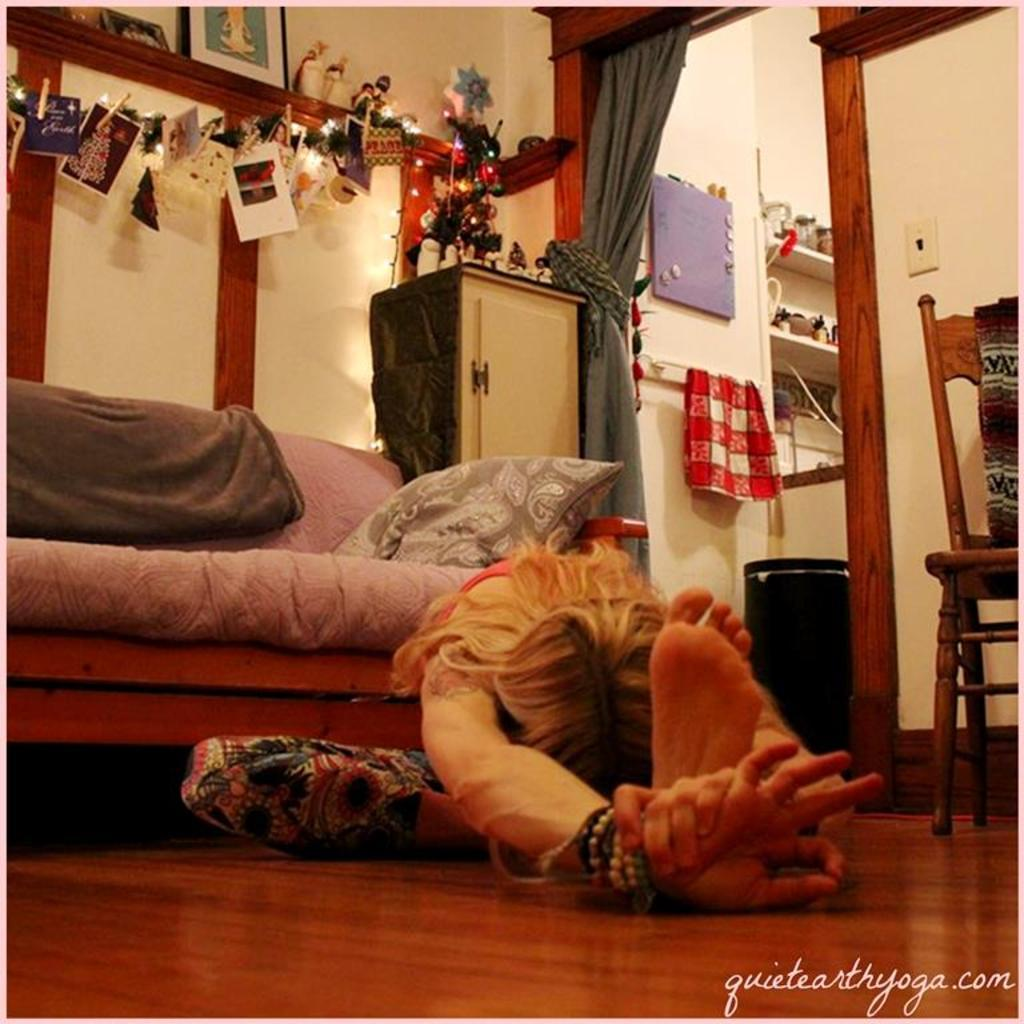What is the person in the image doing? The person is sitting on the floor. What type of furniture is present in the image? There is a sofa and chairs in the image. What holiday decoration can be seen in the image? There is a Christmas tree in the image. What is visible in the background of the image? There is a wall, a curtain, papers, and frames in the background of the image. What type of brake can be seen on the person in the image? There is no brake present in the image; the person is simply sitting on the floor. What purpose does the kite serve in the image? There is no kite present in the image, so it cannot serve any purpose. 